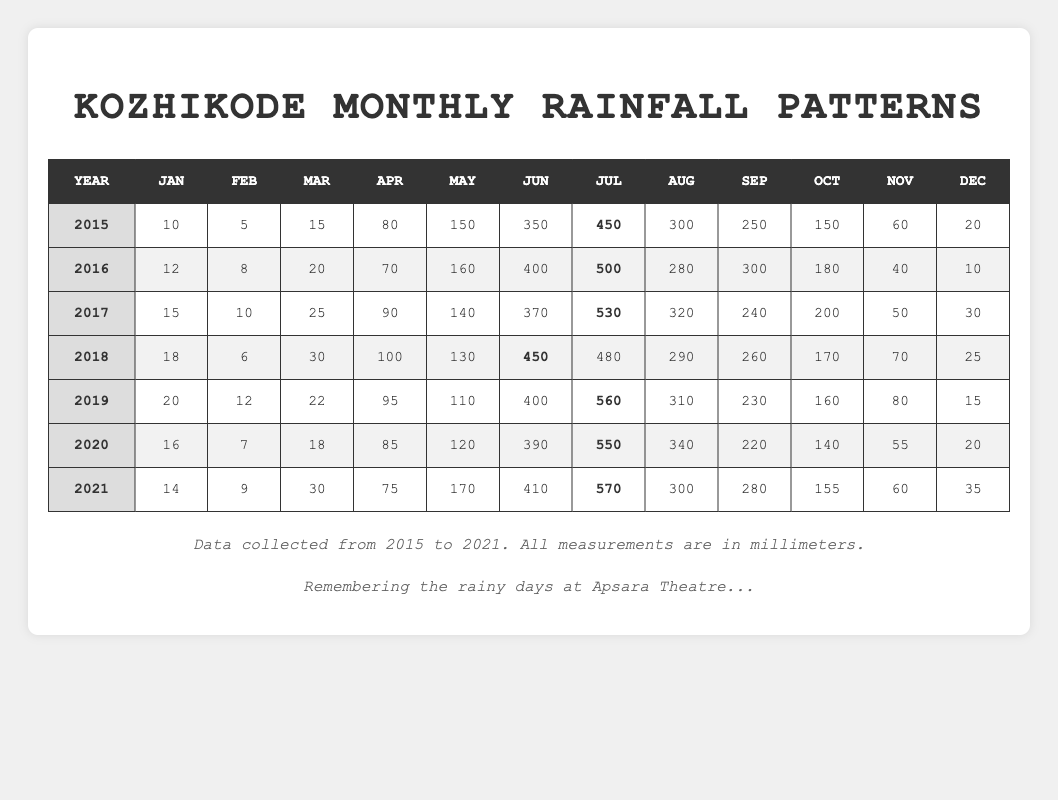What was the total rainfall in Kozhikode for the year 2016? To find the total rainfall for 2016, we add all the monthly data values for that year: 12 + 8 + 20 + 70 + 160 + 400 + 500 + 280 + 300 + 180 + 40 + 10 = 1990 mm.
Answer: 1990 mm Which month had the highest rainfall in 2019? When looking at the monthly data for 2019, July had the highest rainfall with 560 mm compared to the other months.
Answer: July What was the average monthly rainfall across all months in 2020? We sum the monthly values for 2020: 16 + 7 + 18 + 85 + 120 + 390 + 550 + 340 + 220 + 140 + 55 + 20 = 1991 mm. There are 12 months, so we divide 1991 by 12 to get the average: 1991 / 12 = 165.92 mm (approximately 166 mm).
Answer: 166 mm How many years had a total rainfall exceeding 2000 mm? We need to check the total rainfall for each year. The totals are: 2015 - 2055 mm, 2016 - 1990 mm, 2017 - 2140 mm, 2018 - 2105 mm, 2019 - 1990 mm, 2020 - 1991 mm, and 2021 - 2048 mm. The years exceeding 2000 mm are 2015, 2017, 2018, and 2021. Thus, there are 4 years.
Answer: 4 years In which year and month did Kozhikode receive 450 mm of rainfall? Looking through the data, the rainfall of 450 mm occurred in June for the years 2015 and 2018.
Answer: June 2015 and June 2018 Did the rainfall trend increase, decrease, or stay the same from 2015 to 2021? We compare total annual rainfall from 2015 to 2021: 2055 (2015), 1990 (2016), 2140 (2017), 2105 (2018), 1990 (2019), 1991 (2020), 2048 (2021). The data shows fluctuations with increases in some years and decreases in others, indicating variability rather than a clear trend.
Answer: Fluctuated What was the total rainfall for April over all the years provided? Adding the April rainfall amounts: 80 + 70 + 90 + 100 + 95 + 85 + 75 = 695 mm.
Answer: 695 mm Which month had the lowest rainfall in the table, and in which year did it occur? We examine all the monthly values: January in 2015 had the lowest rainfall with 10 mm.
Answer: January 2015 What is the median rainfall for May across the years? The May values are: 150, 160, 140, 130, 110, 120, 170. When sorted: 110, 120, 130, 140, 150, 160, 170, the median (4th value) is 140 mm.
Answer: 140 mm 